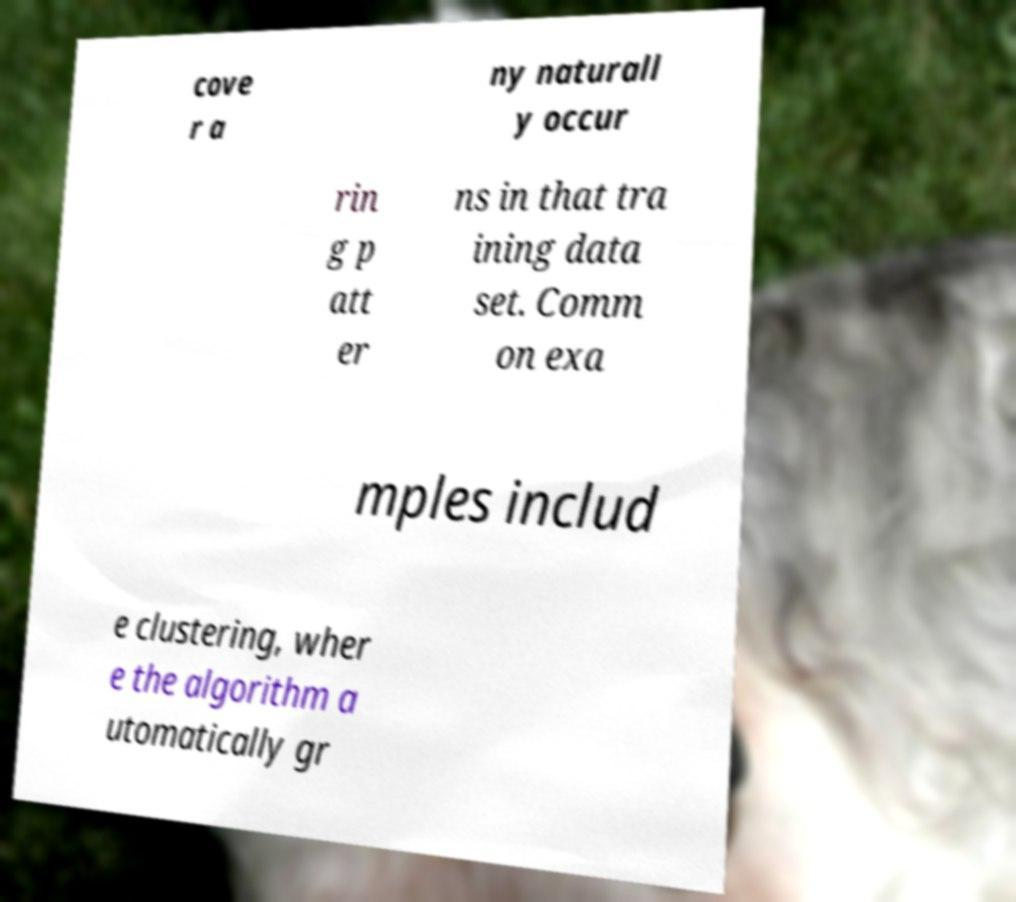Could you extract and type out the text from this image? cove r a ny naturall y occur rin g p att er ns in that tra ining data set. Comm on exa mples includ e clustering, wher e the algorithm a utomatically gr 